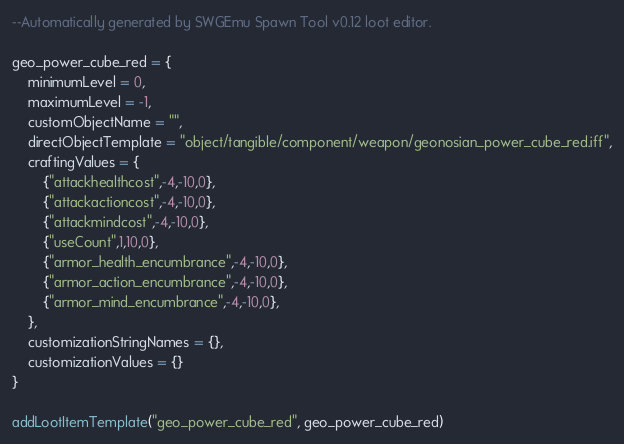<code> <loc_0><loc_0><loc_500><loc_500><_Lua_>--Automatically generated by SWGEmu Spawn Tool v0.12 loot editor.

geo_power_cube_red = {
	minimumLevel = 0,
	maximumLevel = -1,
	customObjectName = "",
	directObjectTemplate = "object/tangible/component/weapon/geonosian_power_cube_red.iff",
	craftingValues = {
		{"attackhealthcost",-4,-10,0},
		{"attackactioncost",-4,-10,0},
		{"attackmindcost",-4,-10,0},
		{"useCount",1,10,0},
		{"armor_health_encumbrance",-4,-10,0},
		{"armor_action_encumbrance",-4,-10,0},
		{"armor_mind_encumbrance",-4,-10,0},
	},
	customizationStringNames = {},
	customizationValues = {}
}

addLootItemTemplate("geo_power_cube_red", geo_power_cube_red)</code> 